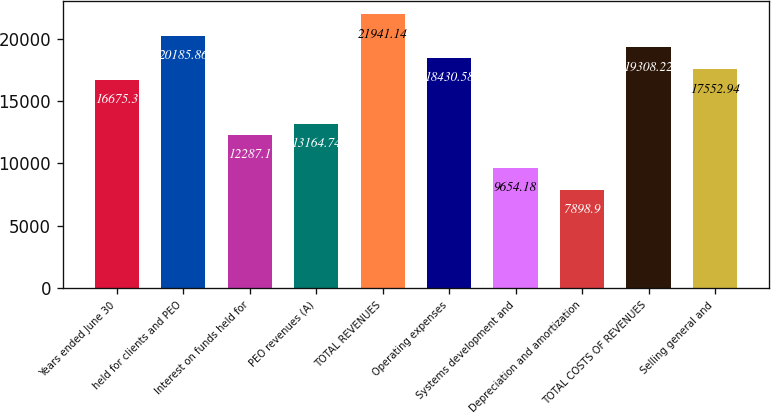<chart> <loc_0><loc_0><loc_500><loc_500><bar_chart><fcel>Years ended June 30<fcel>held for clients and PEO<fcel>Interest on funds held for<fcel>PEO revenues (A)<fcel>TOTAL REVENUES<fcel>Operating expenses<fcel>Systems development and<fcel>Depreciation and amortization<fcel>TOTAL COSTS OF REVENUES<fcel>Selling general and<nl><fcel>16675.3<fcel>20185.9<fcel>12287.1<fcel>13164.7<fcel>21941.1<fcel>18430.6<fcel>9654.18<fcel>7898.9<fcel>19308.2<fcel>17552.9<nl></chart> 